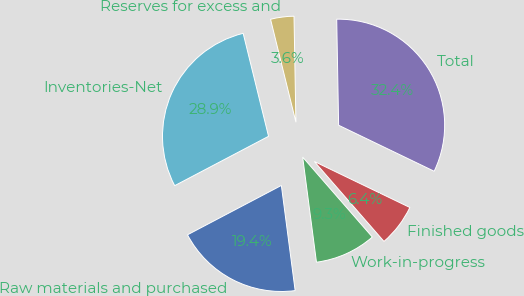Convert chart. <chart><loc_0><loc_0><loc_500><loc_500><pie_chart><fcel>Raw materials and purchased<fcel>Work-in-progress<fcel>Finished goods<fcel>Total<fcel>Reserves for excess and<fcel>Inventories-Net<nl><fcel>19.37%<fcel>9.33%<fcel>6.45%<fcel>32.43%<fcel>3.56%<fcel>28.86%<nl></chart> 